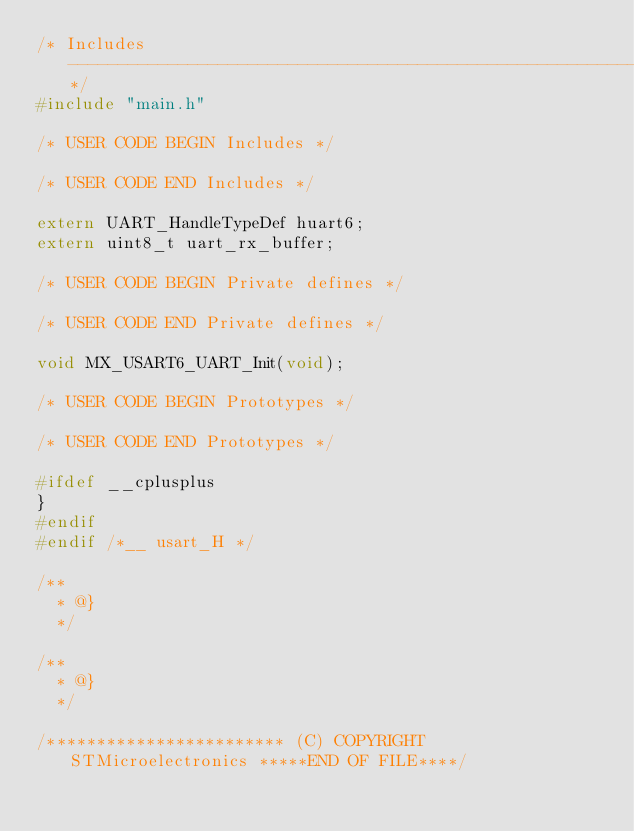<code> <loc_0><loc_0><loc_500><loc_500><_C_>/* Includes ------------------------------------------------------------------*/
#include "main.h"

/* USER CODE BEGIN Includes */

/* USER CODE END Includes */

extern UART_HandleTypeDef huart6;
extern uint8_t uart_rx_buffer;

/* USER CODE BEGIN Private defines */

/* USER CODE END Private defines */

void MX_USART6_UART_Init(void);

/* USER CODE BEGIN Prototypes */

/* USER CODE END Prototypes */

#ifdef __cplusplus
}
#endif
#endif /*__ usart_H */

/**
  * @}
  */

/**
  * @}
  */

/************************ (C) COPYRIGHT STMicroelectronics *****END OF FILE****/
</code> 